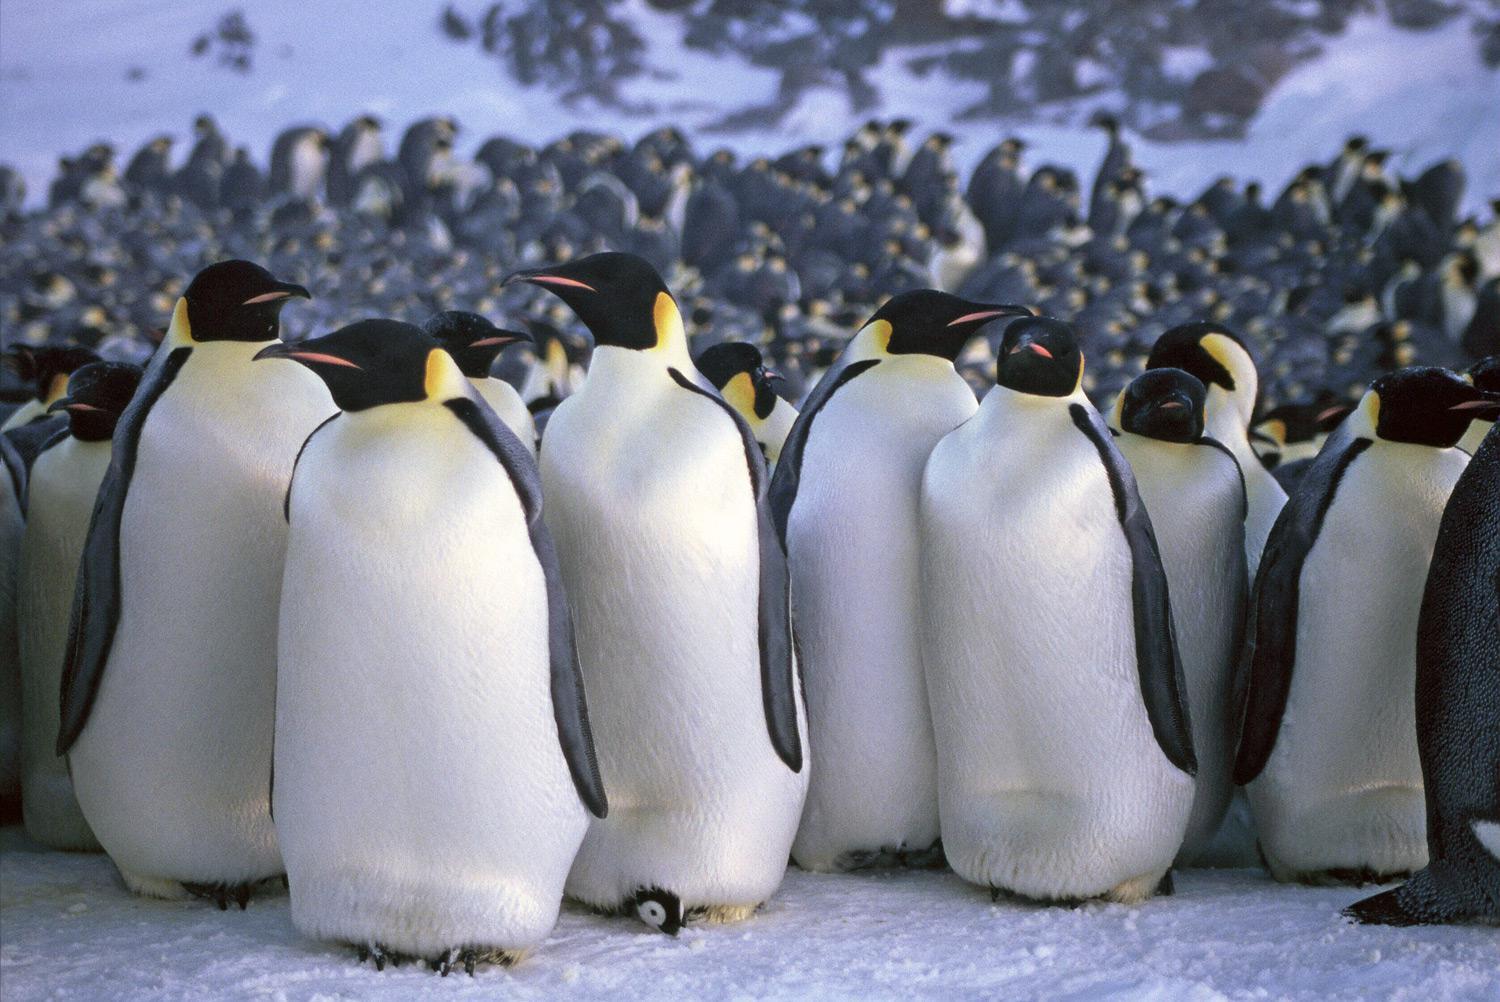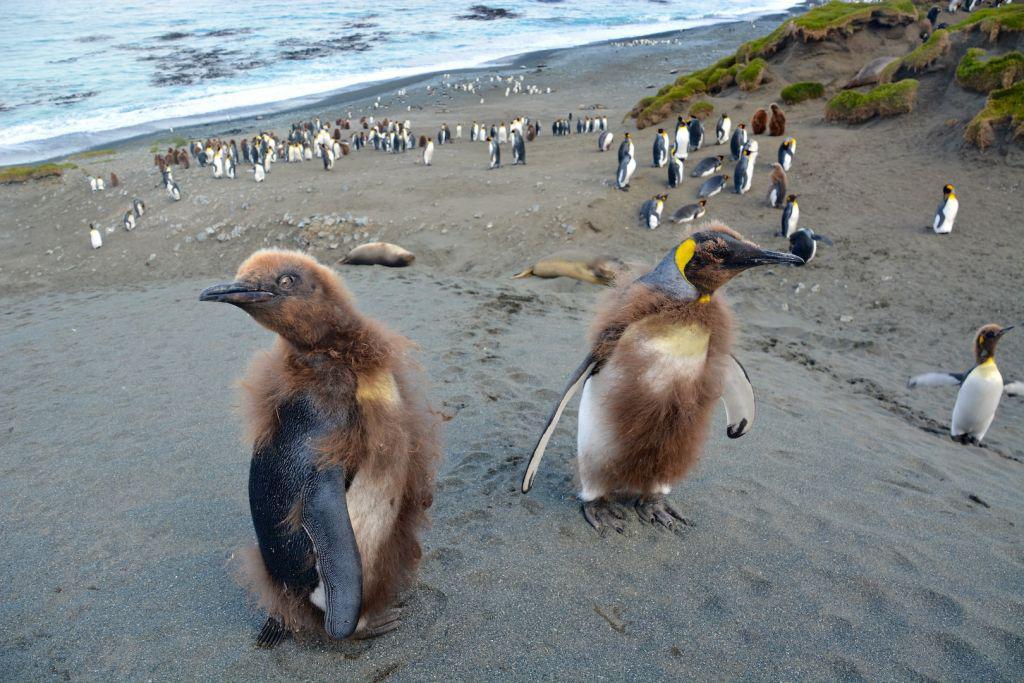The first image is the image on the left, the second image is the image on the right. Evaluate the accuracy of this statement regarding the images: "One of the images features a penguin who is obviously young - still a chick!". Is it true? Answer yes or no. Yes. The first image is the image on the left, the second image is the image on the right. Evaluate the accuracy of this statement regarding the images: "The image on the left shows no more than 7 penguins.". Is it true? Answer yes or no. No. 